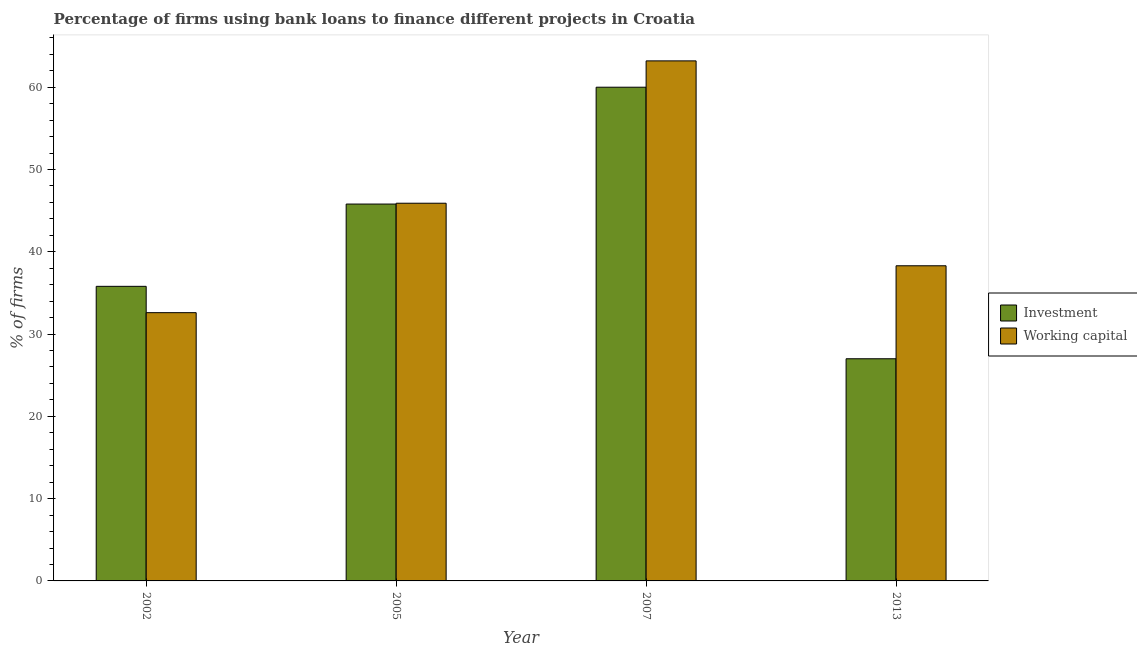How many different coloured bars are there?
Provide a short and direct response. 2. How many groups of bars are there?
Give a very brief answer. 4. Are the number of bars per tick equal to the number of legend labels?
Your answer should be compact. Yes. Are the number of bars on each tick of the X-axis equal?
Offer a very short reply. Yes. What is the label of the 1st group of bars from the left?
Your answer should be compact. 2002. In how many cases, is the number of bars for a given year not equal to the number of legend labels?
Give a very brief answer. 0. What is the percentage of firms using banks to finance investment in 2002?
Keep it short and to the point. 35.8. Across all years, what is the minimum percentage of firms using banks to finance working capital?
Your response must be concise. 32.6. What is the total percentage of firms using banks to finance investment in the graph?
Ensure brevity in your answer.  168.6. What is the difference between the percentage of firms using banks to finance working capital in 2002 and that in 2013?
Provide a succinct answer. -5.7. What is the difference between the percentage of firms using banks to finance working capital in 2007 and the percentage of firms using banks to finance investment in 2002?
Your response must be concise. 30.6. What is the average percentage of firms using banks to finance working capital per year?
Give a very brief answer. 45. In the year 2007, what is the difference between the percentage of firms using banks to finance investment and percentage of firms using banks to finance working capital?
Provide a succinct answer. 0. In how many years, is the percentage of firms using banks to finance investment greater than 60 %?
Make the answer very short. 0. What is the ratio of the percentage of firms using banks to finance investment in 2002 to that in 2013?
Keep it short and to the point. 1.33. What is the difference between the highest and the second highest percentage of firms using banks to finance working capital?
Provide a succinct answer. 17.3. What is the difference between the highest and the lowest percentage of firms using banks to finance working capital?
Make the answer very short. 30.6. Is the sum of the percentage of firms using banks to finance investment in 2007 and 2013 greater than the maximum percentage of firms using banks to finance working capital across all years?
Provide a succinct answer. Yes. What does the 1st bar from the left in 2007 represents?
Offer a terse response. Investment. What does the 1st bar from the right in 2002 represents?
Provide a succinct answer. Working capital. Are all the bars in the graph horizontal?
Make the answer very short. No. How many years are there in the graph?
Provide a short and direct response. 4. Does the graph contain any zero values?
Your response must be concise. No. What is the title of the graph?
Offer a terse response. Percentage of firms using bank loans to finance different projects in Croatia. Does "Under-5(male)" appear as one of the legend labels in the graph?
Ensure brevity in your answer.  No. What is the label or title of the X-axis?
Your answer should be compact. Year. What is the label or title of the Y-axis?
Offer a very short reply. % of firms. What is the % of firms in Investment in 2002?
Keep it short and to the point. 35.8. What is the % of firms in Working capital in 2002?
Give a very brief answer. 32.6. What is the % of firms in Investment in 2005?
Your answer should be compact. 45.8. What is the % of firms of Working capital in 2005?
Ensure brevity in your answer.  45.9. What is the % of firms of Working capital in 2007?
Provide a short and direct response. 63.2. What is the % of firms in Working capital in 2013?
Make the answer very short. 38.3. Across all years, what is the maximum % of firms of Investment?
Offer a terse response. 60. Across all years, what is the maximum % of firms of Working capital?
Ensure brevity in your answer.  63.2. Across all years, what is the minimum % of firms in Investment?
Ensure brevity in your answer.  27. Across all years, what is the minimum % of firms of Working capital?
Offer a very short reply. 32.6. What is the total % of firms of Investment in the graph?
Offer a very short reply. 168.6. What is the total % of firms of Working capital in the graph?
Keep it short and to the point. 180. What is the difference between the % of firms of Working capital in 2002 and that in 2005?
Make the answer very short. -13.3. What is the difference between the % of firms of Investment in 2002 and that in 2007?
Offer a very short reply. -24.2. What is the difference between the % of firms of Working capital in 2002 and that in 2007?
Your response must be concise. -30.6. What is the difference between the % of firms of Working capital in 2002 and that in 2013?
Ensure brevity in your answer.  -5.7. What is the difference between the % of firms in Investment in 2005 and that in 2007?
Offer a very short reply. -14.2. What is the difference between the % of firms of Working capital in 2005 and that in 2007?
Provide a short and direct response. -17.3. What is the difference between the % of firms in Working capital in 2005 and that in 2013?
Give a very brief answer. 7.6. What is the difference between the % of firms of Investment in 2007 and that in 2013?
Your answer should be very brief. 33. What is the difference between the % of firms in Working capital in 2007 and that in 2013?
Keep it short and to the point. 24.9. What is the difference between the % of firms in Investment in 2002 and the % of firms in Working capital in 2007?
Offer a terse response. -27.4. What is the difference between the % of firms of Investment in 2005 and the % of firms of Working capital in 2007?
Provide a short and direct response. -17.4. What is the difference between the % of firms in Investment in 2005 and the % of firms in Working capital in 2013?
Your answer should be compact. 7.5. What is the difference between the % of firms in Investment in 2007 and the % of firms in Working capital in 2013?
Ensure brevity in your answer.  21.7. What is the average % of firms in Investment per year?
Make the answer very short. 42.15. What is the average % of firms in Working capital per year?
Your answer should be very brief. 45. In the year 2002, what is the difference between the % of firms of Investment and % of firms of Working capital?
Offer a terse response. 3.2. In the year 2007, what is the difference between the % of firms of Investment and % of firms of Working capital?
Provide a short and direct response. -3.2. In the year 2013, what is the difference between the % of firms of Investment and % of firms of Working capital?
Your response must be concise. -11.3. What is the ratio of the % of firms in Investment in 2002 to that in 2005?
Your answer should be very brief. 0.78. What is the ratio of the % of firms in Working capital in 2002 to that in 2005?
Provide a succinct answer. 0.71. What is the ratio of the % of firms of Investment in 2002 to that in 2007?
Offer a terse response. 0.6. What is the ratio of the % of firms in Working capital in 2002 to that in 2007?
Your response must be concise. 0.52. What is the ratio of the % of firms of Investment in 2002 to that in 2013?
Ensure brevity in your answer.  1.33. What is the ratio of the % of firms in Working capital in 2002 to that in 2013?
Ensure brevity in your answer.  0.85. What is the ratio of the % of firms of Investment in 2005 to that in 2007?
Give a very brief answer. 0.76. What is the ratio of the % of firms in Working capital in 2005 to that in 2007?
Make the answer very short. 0.73. What is the ratio of the % of firms of Investment in 2005 to that in 2013?
Make the answer very short. 1.7. What is the ratio of the % of firms in Working capital in 2005 to that in 2013?
Make the answer very short. 1.2. What is the ratio of the % of firms of Investment in 2007 to that in 2013?
Make the answer very short. 2.22. What is the ratio of the % of firms of Working capital in 2007 to that in 2013?
Give a very brief answer. 1.65. What is the difference between the highest and the second highest % of firms in Working capital?
Make the answer very short. 17.3. What is the difference between the highest and the lowest % of firms of Working capital?
Offer a very short reply. 30.6. 